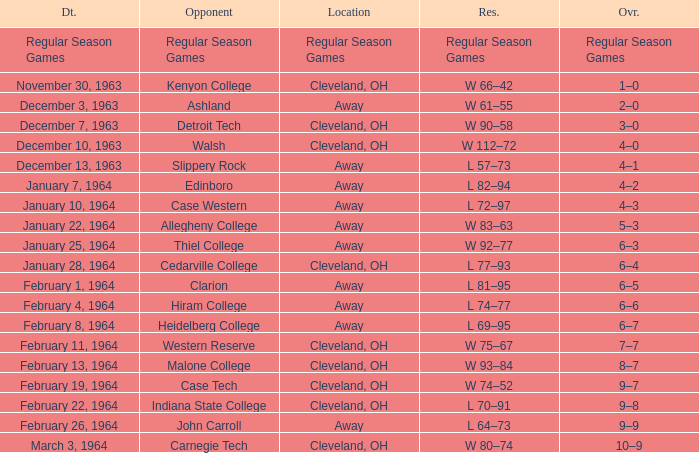Would you be able to parse every entry in this table? {'header': ['Dt.', 'Opponent', 'Location', 'Res.', 'Ovr.'], 'rows': [['Regular Season Games', 'Regular Season Games', 'Regular Season Games', 'Regular Season Games', 'Regular Season Games'], ['November 30, 1963', 'Kenyon College', 'Cleveland, OH', 'W 66–42', '1–0'], ['December 3, 1963', 'Ashland', 'Away', 'W 61–55', '2–0'], ['December 7, 1963', 'Detroit Tech', 'Cleveland, OH', 'W 90–58', '3–0'], ['December 10, 1963', 'Walsh', 'Cleveland, OH', 'W 112–72', '4–0'], ['December 13, 1963', 'Slippery Rock', 'Away', 'L 57–73', '4–1'], ['January 7, 1964', 'Edinboro', 'Away', 'L 82–94', '4–2'], ['January 10, 1964', 'Case Western', 'Away', 'L 72–97', '4–3'], ['January 22, 1964', 'Allegheny College', 'Away', 'W 83–63', '5–3'], ['January 25, 1964', 'Thiel College', 'Away', 'W 92–77', '6–3'], ['January 28, 1964', 'Cedarville College', 'Cleveland, OH', 'L 77–93', '6–4'], ['February 1, 1964', 'Clarion', 'Away', 'L 81–95', '6–5'], ['February 4, 1964', 'Hiram College', 'Away', 'L 74–77', '6–6'], ['February 8, 1964', 'Heidelberg College', 'Away', 'L 69–95', '6–7'], ['February 11, 1964', 'Western Reserve', 'Cleveland, OH', 'W 75–67', '7–7'], ['February 13, 1964', 'Malone College', 'Cleveland, OH', 'W 93–84', '8–7'], ['February 19, 1964', 'Case Tech', 'Cleveland, OH', 'W 74–52', '9–7'], ['February 22, 1964', 'Indiana State College', 'Cleveland, OH', 'L 70–91', '9–8'], ['February 26, 1964', 'John Carroll', 'Away', 'L 64–73', '9–9'], ['March 3, 1964', 'Carnegie Tech', 'Cleveland, OH', 'W 80–74', '10–9']]} What is the Overall with a Date that is february 4, 1964? 6–6. 